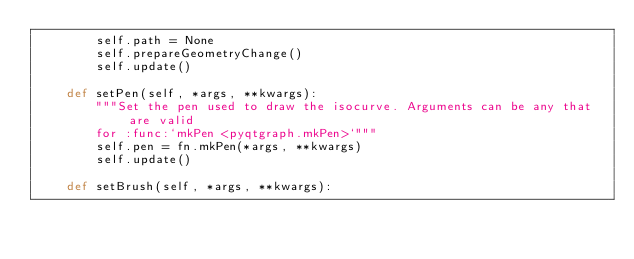<code> <loc_0><loc_0><loc_500><loc_500><_Python_>        self.path = None
        self.prepareGeometryChange()
        self.update()

    def setPen(self, *args, **kwargs):
        """Set the pen used to draw the isocurve. Arguments can be any that are valid 
        for :func:`mkPen <pyqtgraph.mkPen>`"""
        self.pen = fn.mkPen(*args, **kwargs)
        self.update()

    def setBrush(self, *args, **kwargs):</code> 